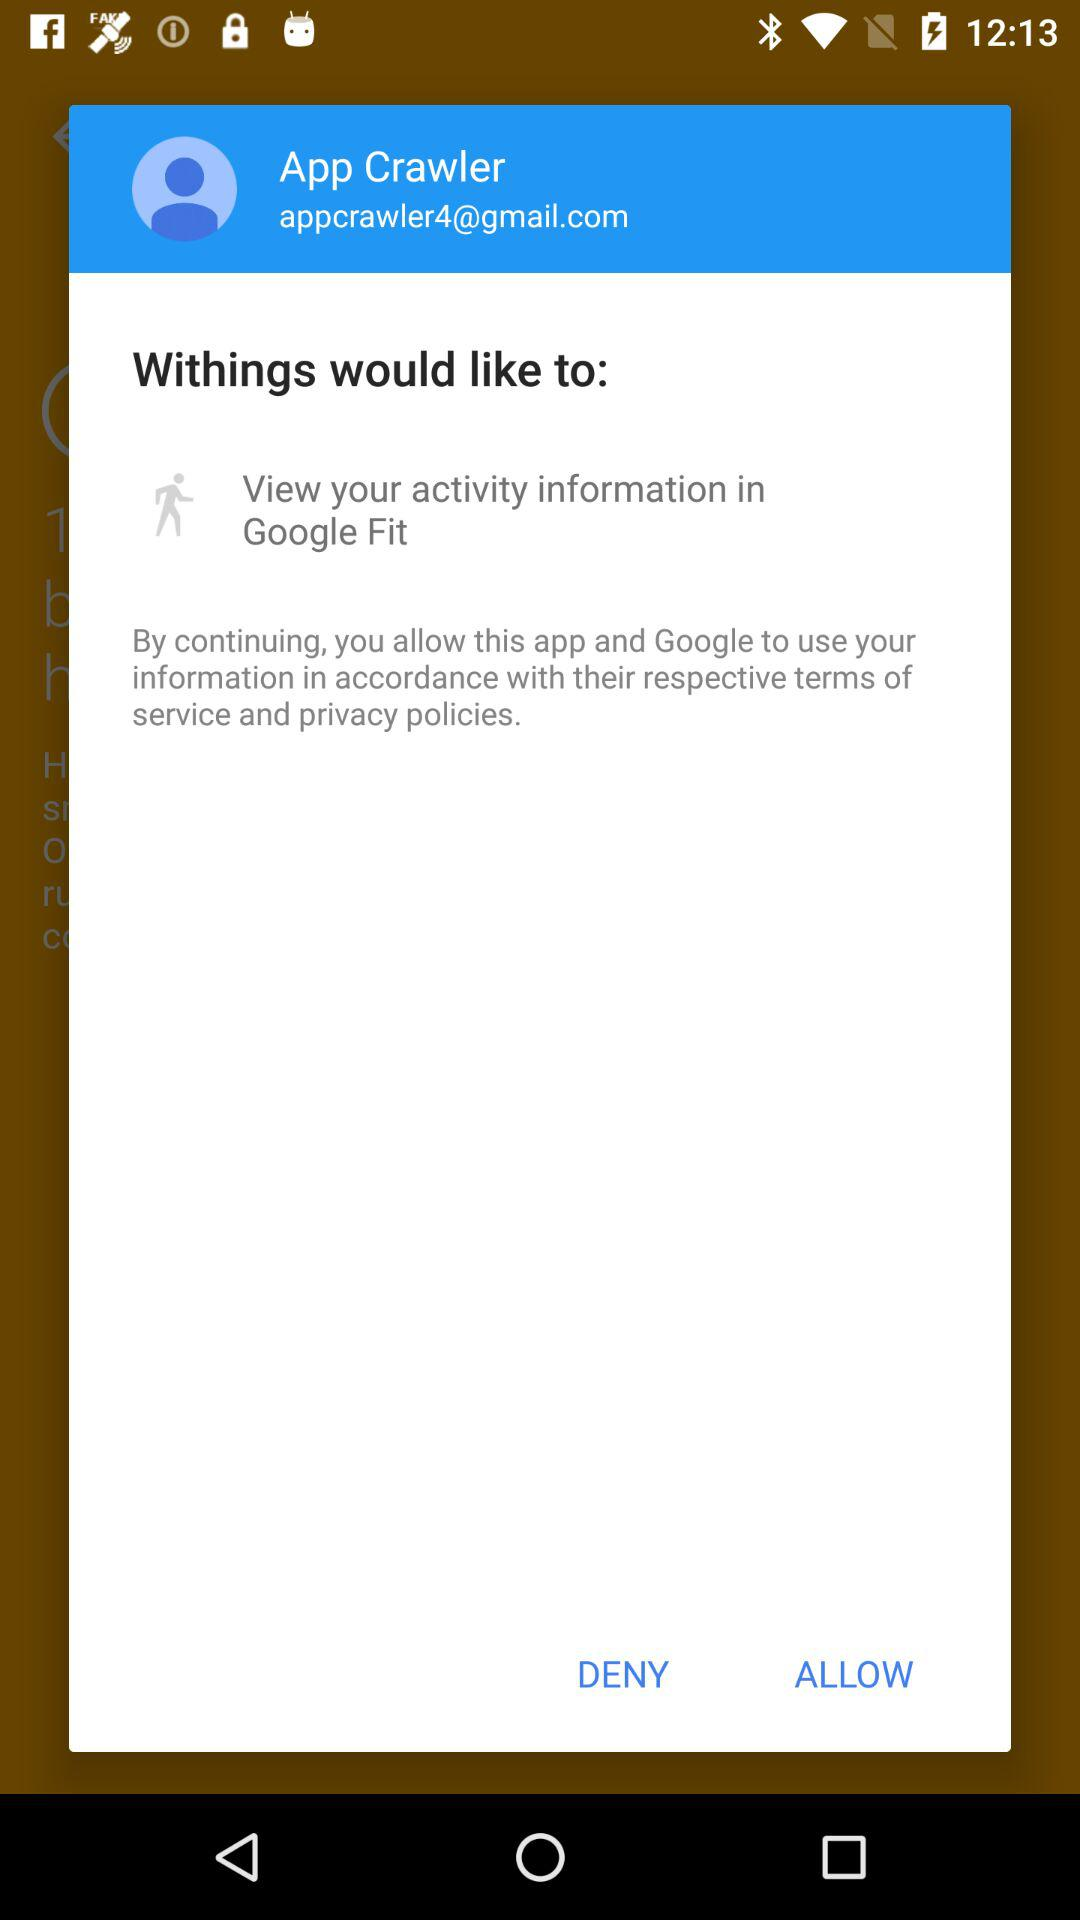What is the name of the application? The name of the application is "Withings". 